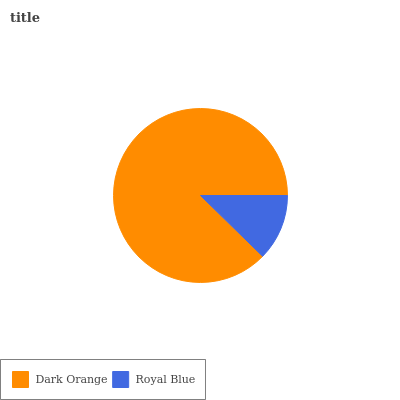Is Royal Blue the minimum?
Answer yes or no. Yes. Is Dark Orange the maximum?
Answer yes or no. Yes. Is Royal Blue the maximum?
Answer yes or no. No. Is Dark Orange greater than Royal Blue?
Answer yes or no. Yes. Is Royal Blue less than Dark Orange?
Answer yes or no. Yes. Is Royal Blue greater than Dark Orange?
Answer yes or no. No. Is Dark Orange less than Royal Blue?
Answer yes or no. No. Is Dark Orange the high median?
Answer yes or no. Yes. Is Royal Blue the low median?
Answer yes or no. Yes. Is Royal Blue the high median?
Answer yes or no. No. Is Dark Orange the low median?
Answer yes or no. No. 